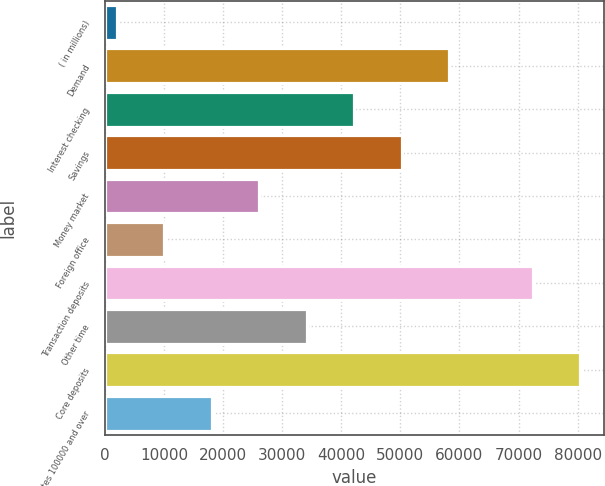<chart> <loc_0><loc_0><loc_500><loc_500><bar_chart><fcel>( in millions)<fcel>Demand<fcel>Interest checking<fcel>Savings<fcel>Money market<fcel>Foreign office<fcel>Transaction deposits<fcel>Other time<fcel>Core deposits<fcel>Certificates 100000 and over<nl><fcel>2011<fcel>58223.8<fcel>42163<fcel>50193.4<fcel>26102.2<fcel>10041.4<fcel>72392<fcel>34132.6<fcel>80422.4<fcel>18071.8<nl></chart> 